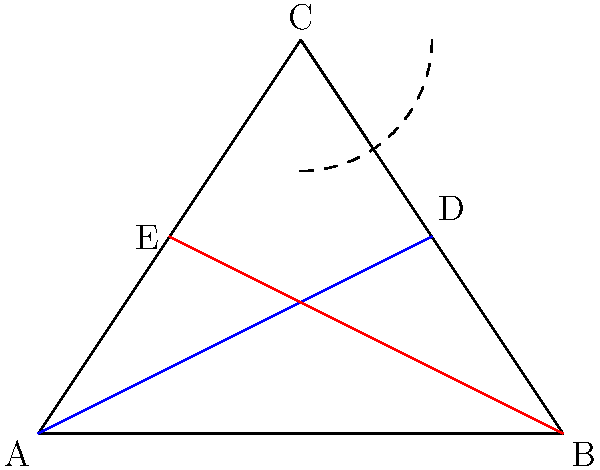In hyperbolic geometry, consider two lines that are parallel at a point C. As these lines extend away from C, they begin to diverge. If we measure the distance between these parallel lines at points A and B, which are equidistant from C, how would this distance compare to the distance between the lines at C? Explain your reasoning using the principles of hyperbolic geometry and the curvature of space. To answer this question, let's consider the fundamental principles of hyperbolic geometry:

1. In hyperbolic geometry, space has a constant negative curvature, unlike Euclidean geometry where space is flat.

2. This negative curvature affects the behavior of parallel lines. In hyperbolic geometry, parallel lines diverge from each other as they extend away from a common point.

3. The divergence of parallel lines is a direct consequence of the negative curvature of space. As we move along these lines, the space between them expands due to the geometry of hyperbolic space.

4. In the diagram, the blue and red lines represent our parallel lines in hyperbolic space. Point C is where they are initially parallel.

5. Points A and B are equidistant from C, representing two locations where we might measure the distance between the parallel lines.

6. Due to the negative curvature of hyperbolic space, the distance between the parallel lines at A and B will be greater than the distance at C.

7. This can be visualized by imagining the surface of a saddle. As you move away from the center of the saddle, the surface curves away in all directions, causing initially parallel paths to diverge.

8. Mathematically, if we denote the distance between the lines at C as $d_C$, and the distance at A or B as $d_A$ or $d_B$, we would find that $d_A = d_B > d_C$.

9. The rate of divergence is related to the magnitude of the negative curvature of the space. A more pronounced negative curvature would result in a faster rate of divergence.
Answer: The distance between the parallel lines at A and B would be greater than the distance at C due to the negative curvature of hyperbolic space causing parallel lines to diverge. 